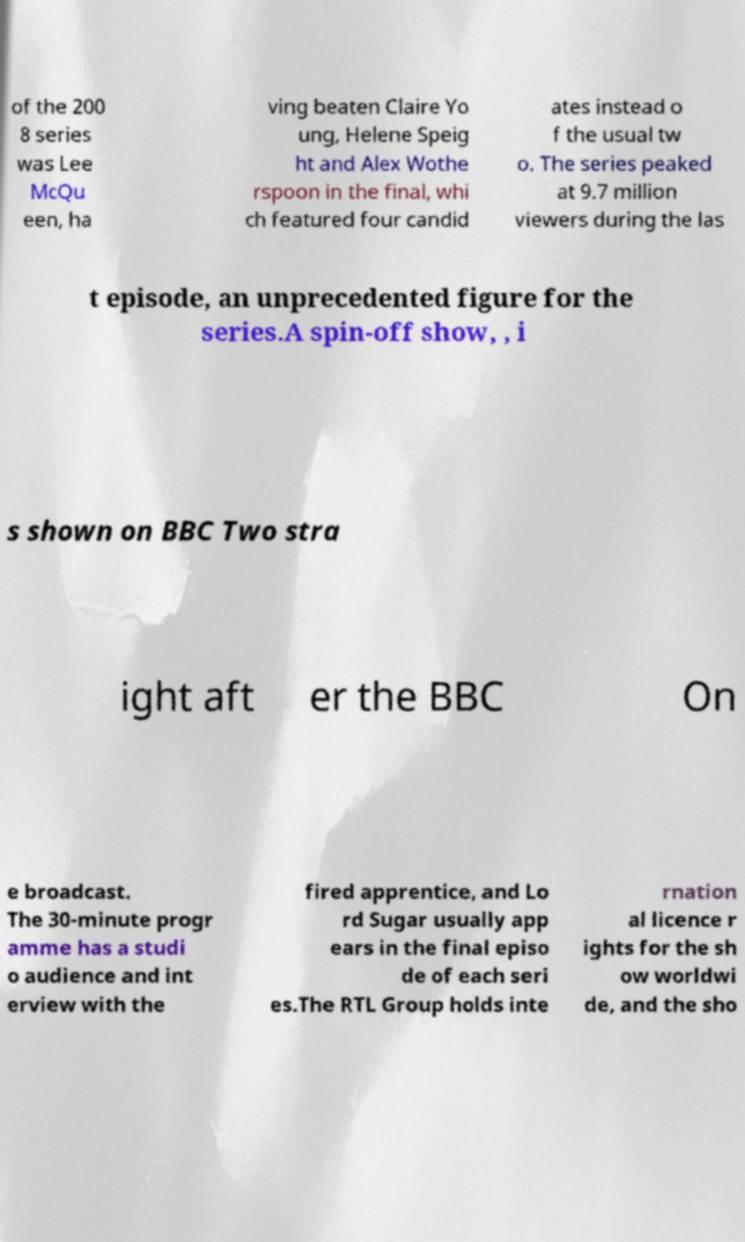Can you accurately transcribe the text from the provided image for me? of the 200 8 series was Lee McQu een, ha ving beaten Claire Yo ung, Helene Speig ht and Alex Wothe rspoon in the final, whi ch featured four candid ates instead o f the usual tw o. The series peaked at 9.7 million viewers during the las t episode, an unprecedented figure for the series.A spin-off show, , i s shown on BBC Two stra ight aft er the BBC On e broadcast. The 30-minute progr amme has a studi o audience and int erview with the fired apprentice, and Lo rd Sugar usually app ears in the final episo de of each seri es.The RTL Group holds inte rnation al licence r ights for the sh ow worldwi de, and the sho 